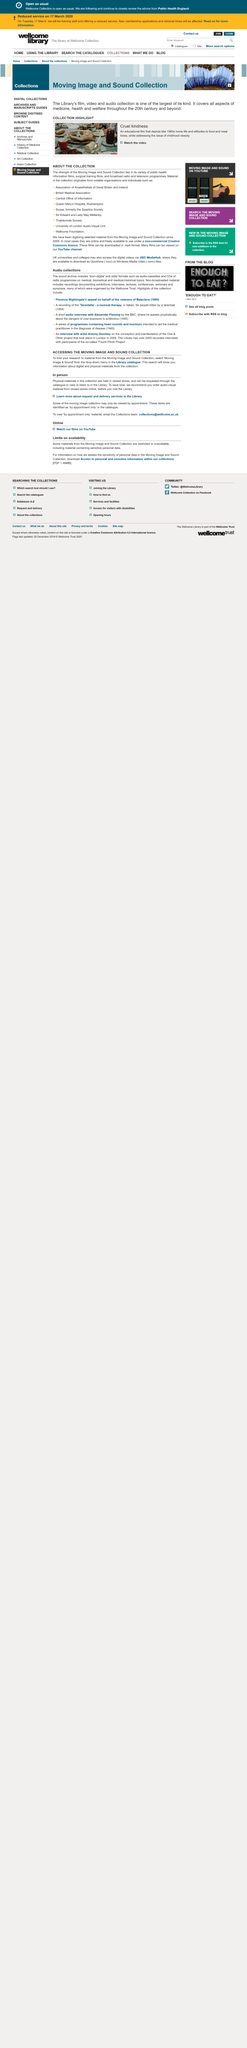Indicate a few pertinent items in this graphic. Digital materials are electronic assets that are designed to be viewed on electronic devices such as mobile phones or computers. A physical material is defined as one that is held at a library or closed store. Visiting the library in person means physically going to the library after or before searching for materials online or not searching for materials online at all. 